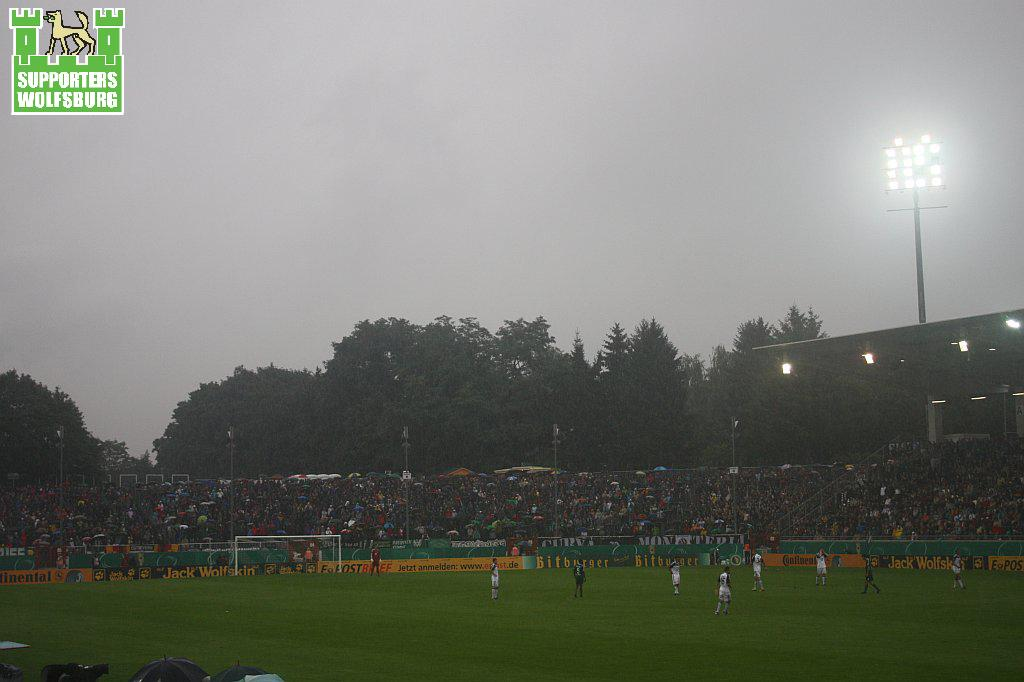What can be seen in the sky in the image? The sky is visible in the image. What type of lighting is present in the image? There are flood lights in the image. What type of vegetation is present in the image? Trees are present in the image. What type of structures are visible in the image? Poles are visible in the image. Who is present in the image? Spectators and persons are standing in the ground in the image. What type of objects are present for shade or decoration? Parasols are present in the image. What type of signage is present in the image? Advertisement boards are in the image. What type of needle is being used by the geese in the image? There are no geese or needles present in the image. How does the cork float in the image? There is no cork present in the image. 